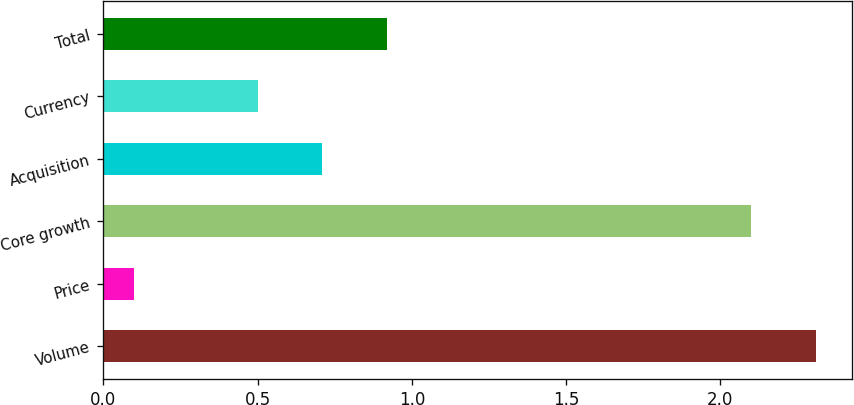<chart> <loc_0><loc_0><loc_500><loc_500><bar_chart><fcel>Volume<fcel>Price<fcel>Core growth<fcel>Acquisition<fcel>Currency<fcel>Total<nl><fcel>2.31<fcel>0.1<fcel>2.1<fcel>0.71<fcel>0.5<fcel>0.92<nl></chart> 